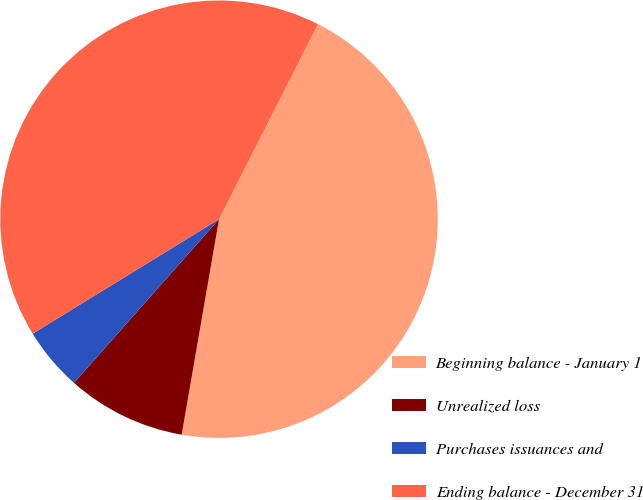<chart> <loc_0><loc_0><loc_500><loc_500><pie_chart><fcel>Beginning balance - January 1<fcel>Unrealized loss<fcel>Purchases issuances and<fcel>Ending balance - December 31<nl><fcel>45.26%<fcel>8.81%<fcel>4.69%<fcel>41.24%<nl></chart> 